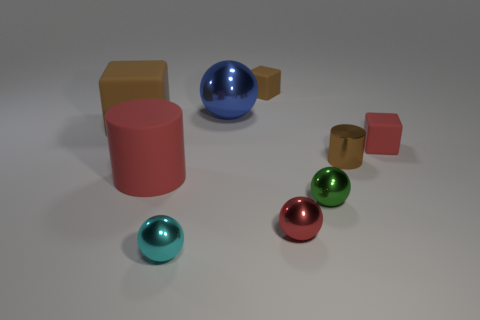What size is the cyan metal thing?
Make the answer very short. Small. How many objects are cyan spheres or red cubes?
Make the answer very short. 2. The big sphere that is made of the same material as the tiny brown cylinder is what color?
Make the answer very short. Blue. There is a large rubber object that is in front of the large matte cube; is its shape the same as the tiny green object?
Ensure brevity in your answer.  No. What number of objects are blocks right of the tiny brown cube or small shiny spheres to the left of the blue metallic sphere?
Keep it short and to the point. 2. There is another big thing that is the same shape as the green metallic object; what is its color?
Give a very brief answer. Blue. Are there any other things that are the same shape as the red metal object?
Give a very brief answer. Yes. There is a brown metallic object; does it have the same shape as the red rubber object that is left of the tiny red matte thing?
Ensure brevity in your answer.  Yes. What is the red cube made of?
Offer a very short reply. Rubber. What is the size of the red thing that is the same shape as the blue thing?
Give a very brief answer. Small. 